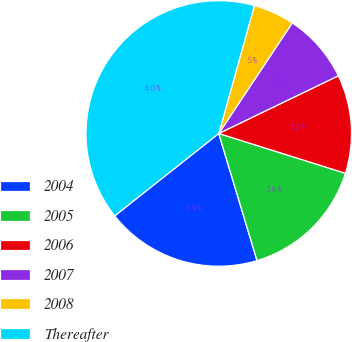<chart> <loc_0><loc_0><loc_500><loc_500><pie_chart><fcel>2004<fcel>2005<fcel>2006<fcel>2007<fcel>2008<fcel>Thereafter<nl><fcel>19.0%<fcel>15.5%<fcel>12.0%<fcel>8.51%<fcel>5.01%<fcel>39.98%<nl></chart> 